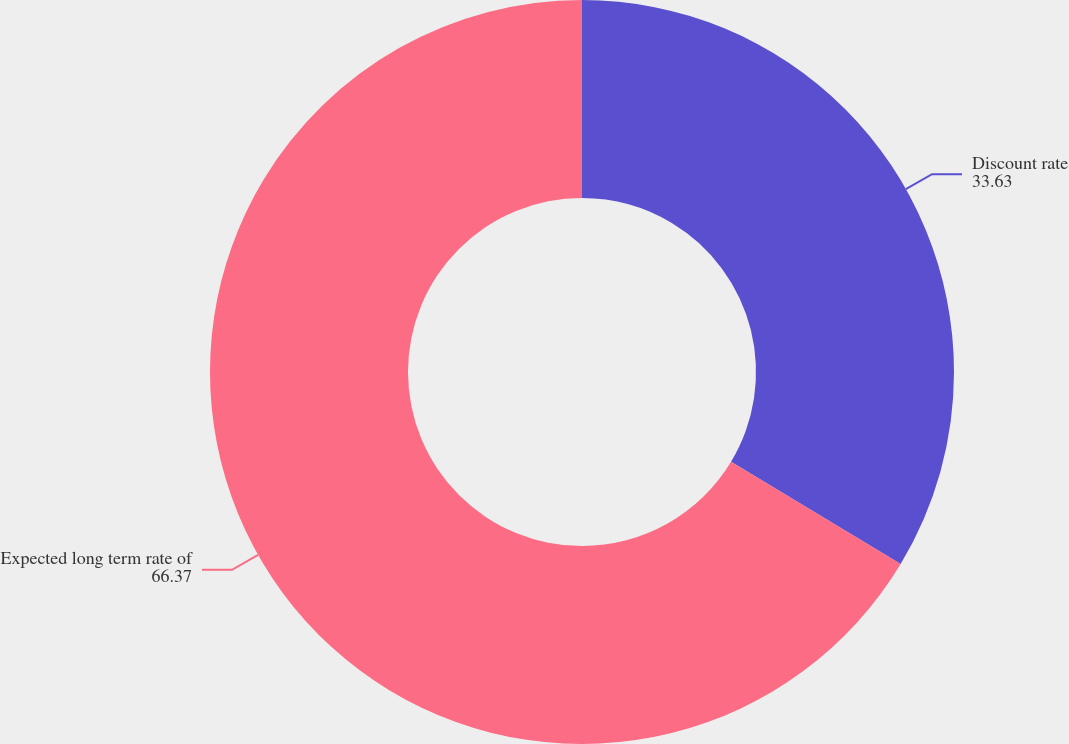Convert chart. <chart><loc_0><loc_0><loc_500><loc_500><pie_chart><fcel>Discount rate<fcel>Expected long term rate of<nl><fcel>33.63%<fcel>66.37%<nl></chart> 